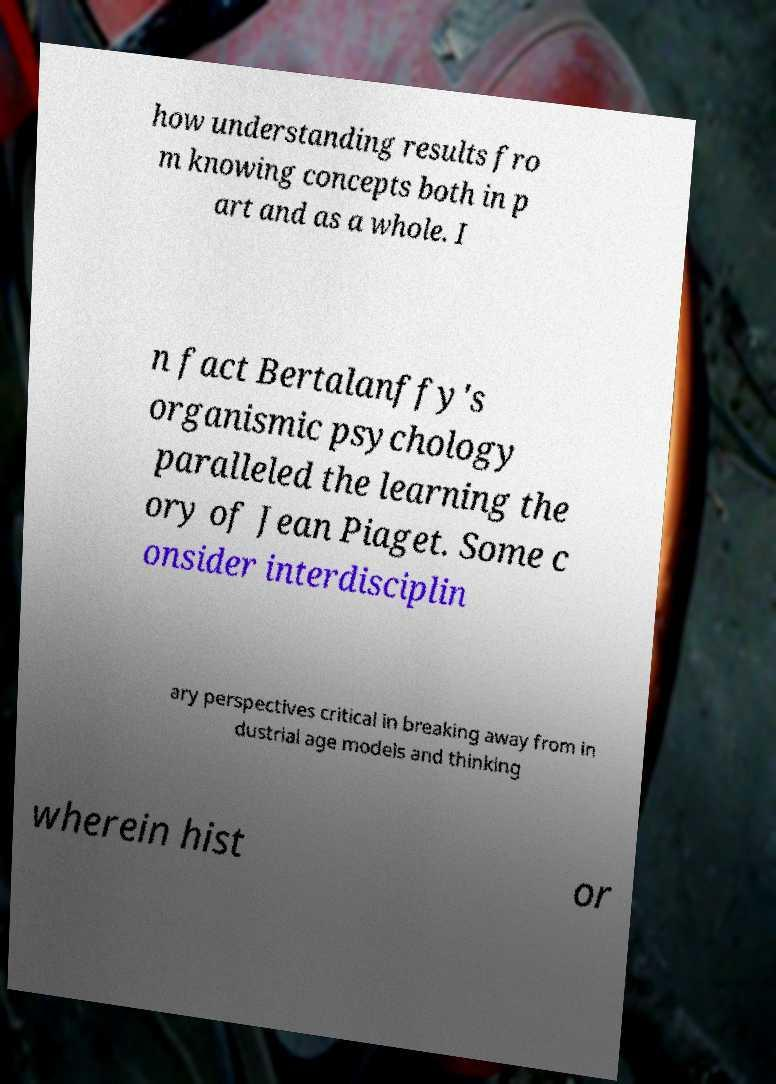I need the written content from this picture converted into text. Can you do that? how understanding results fro m knowing concepts both in p art and as a whole. I n fact Bertalanffy's organismic psychology paralleled the learning the ory of Jean Piaget. Some c onsider interdisciplin ary perspectives critical in breaking away from in dustrial age models and thinking wherein hist or 